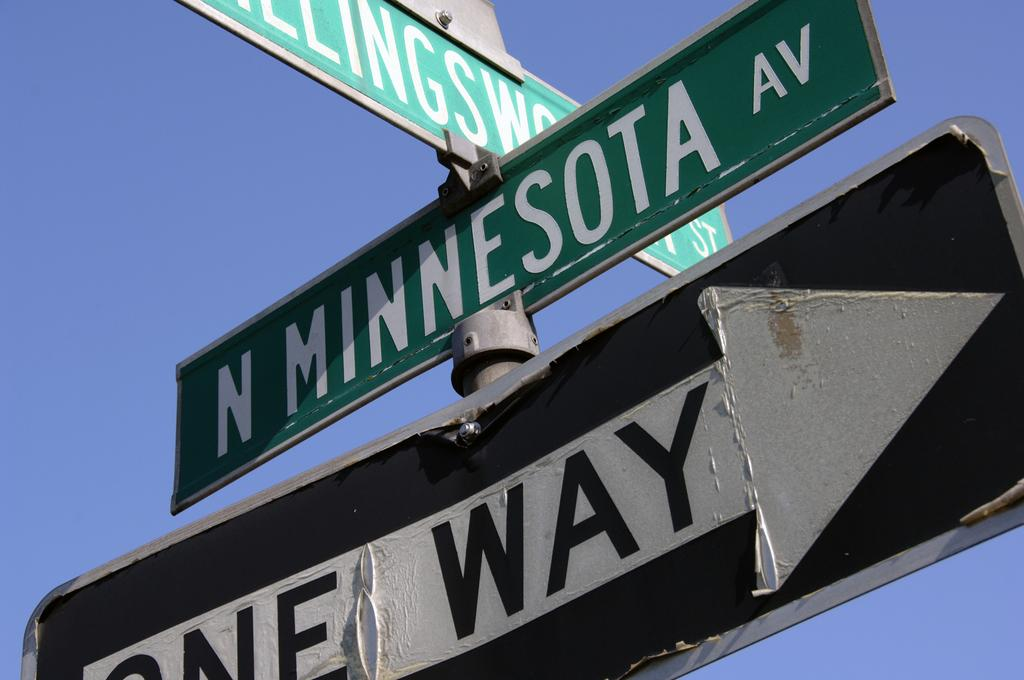<image>
Share a concise interpretation of the image provided. A street sign for N MINNESOTA AVE is mounted above a ONE WAY sign. 